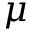<formula> <loc_0><loc_0><loc_500><loc_500>\mu</formula> 